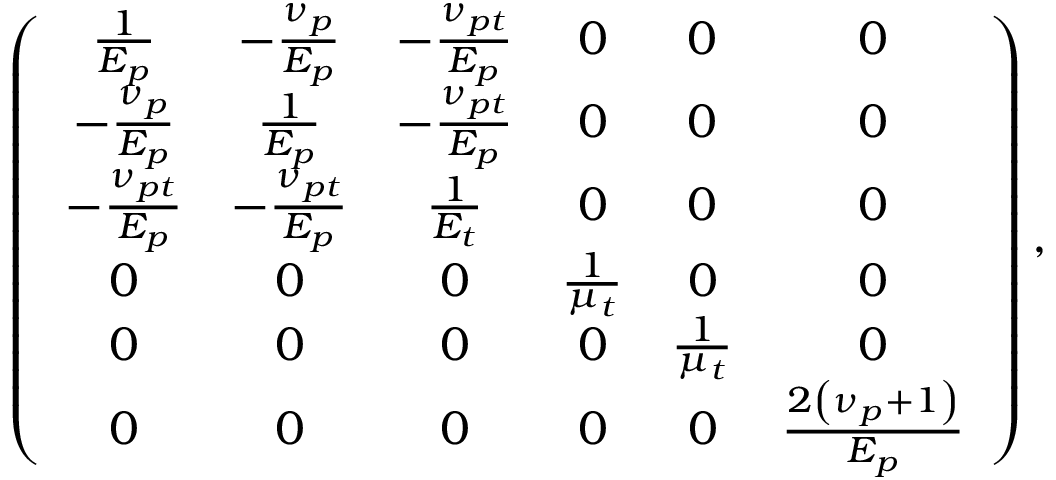<formula> <loc_0><loc_0><loc_500><loc_500>\left ( \begin{array} { c c c c c c } { \frac { 1 } { E _ { p } } } & { - \frac { \nu _ { p } } { E _ { p } } } & { - \frac { \nu _ { p t } } { E _ { p } } } & { 0 } & { 0 } & { 0 } \\ { - \frac { \nu _ { p } } { E _ { p } } } & { \frac { 1 } { E _ { p } } } & { - \frac { \nu _ { p t } } { E _ { p } } } & { 0 } & { 0 } & { 0 } \\ { - \frac { \nu _ { p t } } { E _ { p } } } & { - \frac { \nu _ { p t } } { E _ { p } } } & { \frac { 1 } { E _ { t } } } & { 0 } & { 0 } & { 0 } \\ { 0 } & { 0 } & { 0 } & { \frac { 1 } { \mu _ { t } } } & { 0 } & { 0 } \\ { 0 } & { 0 } & { 0 } & { 0 } & { \frac { 1 } { \mu _ { t } } } & { 0 } \\ { 0 } & { 0 } & { 0 } & { 0 } & { 0 } & { \frac { 2 \left ( \nu _ { p } + 1 \right ) } { E _ { p } } } \end{array} \right ) ,</formula> 